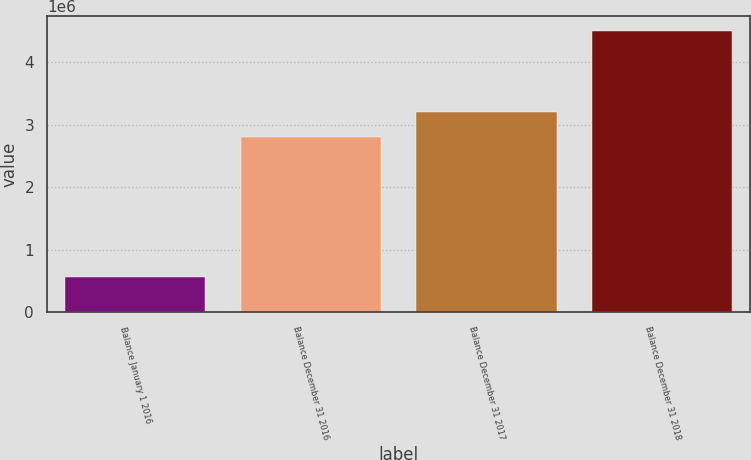<chart> <loc_0><loc_0><loc_500><loc_500><bar_chart><fcel>Balance January 1 2016<fcel>Balance December 31 2016<fcel>Balance December 31 2017<fcel>Balance December 31 2018<nl><fcel>556467<fcel>2.80895e+06<fcel>3.20452e+06<fcel>4.5122e+06<nl></chart> 